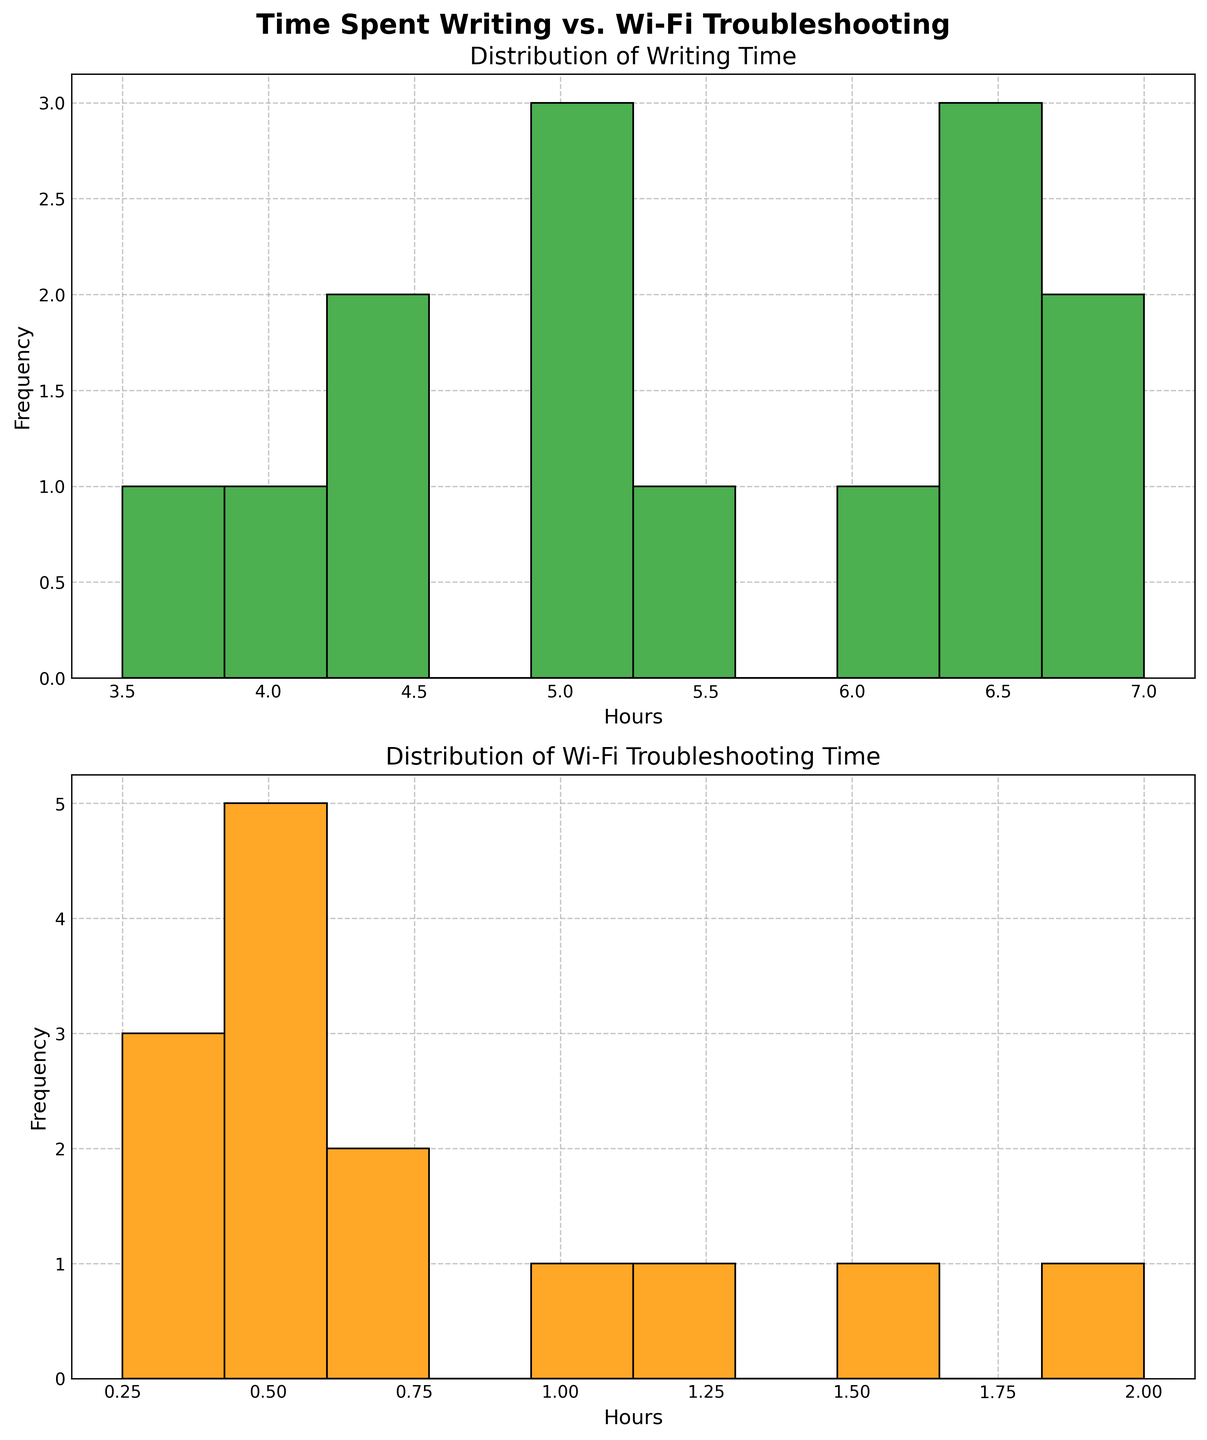What is the title of the first subplot? The first subplot shows a histogram of the time spent writing. The title is located at the top of the subplot.
Answer: Distribution of Writing Time How are the x-axis labels marked on the second subplot? The x-axis labels on the second subplot indicate the hours spent troubleshooting Wi-Fi problems, which are marked in intervals representing the histogram bins.
Answer: Hours What is the most frequent writing time seen in the data? Check the histogram bars to see which bin has the highest frequency in the first subplot. The bin with the highest bar represents the most frequent writing time.
Answer: 5-6 hours Which subplot shows the distribution of Wi-Fi troubleshooting time? There are two subplots, and the one that corresponds to the Wi-Fi troubleshooting time is identified by its title and x-axis labels related to Wi-Fi troubleshooting.
Answer: The second subplot What is the highest frequency seen in the Wi-Fi troubleshooting time histogram? Look at the highest bar in the Wi-Fi troubleshooting time histogram to identify the highest frequency value.
Answer: 5 What day has the highest Wi-Fi troubleshooting time? The day with the highest Wi-Fi troubleshooting time can be found by looking at the data table where it states 'Friday' with values up to 2.0 hours. You know this from the data that would correspond to the higher bin on the second histogram.
Answer: Friday Compare the total writing time for Monday and Sunday. Which day has a higher sum? To compare total writing time, sum up the hours for each day in the data, then compare totals for Monday and Sunday.
Answer: Monday Is there any day where the Wi-Fi troubleshooting time was the same amount as the writing time? Compare the values in the data table for each day; find the day when both values are the same amount. This can be complex as none of the given values in the data directly matches both fields for the same day, so the correct answer is no.
Answer: No What is the range of hours spent in Wi-Fi troubleshooting time? The range is calculated by finding the difference between the maximum and minimum values of Wi-Fi troubleshooting time in the data.
Answer: 1.75 hours 